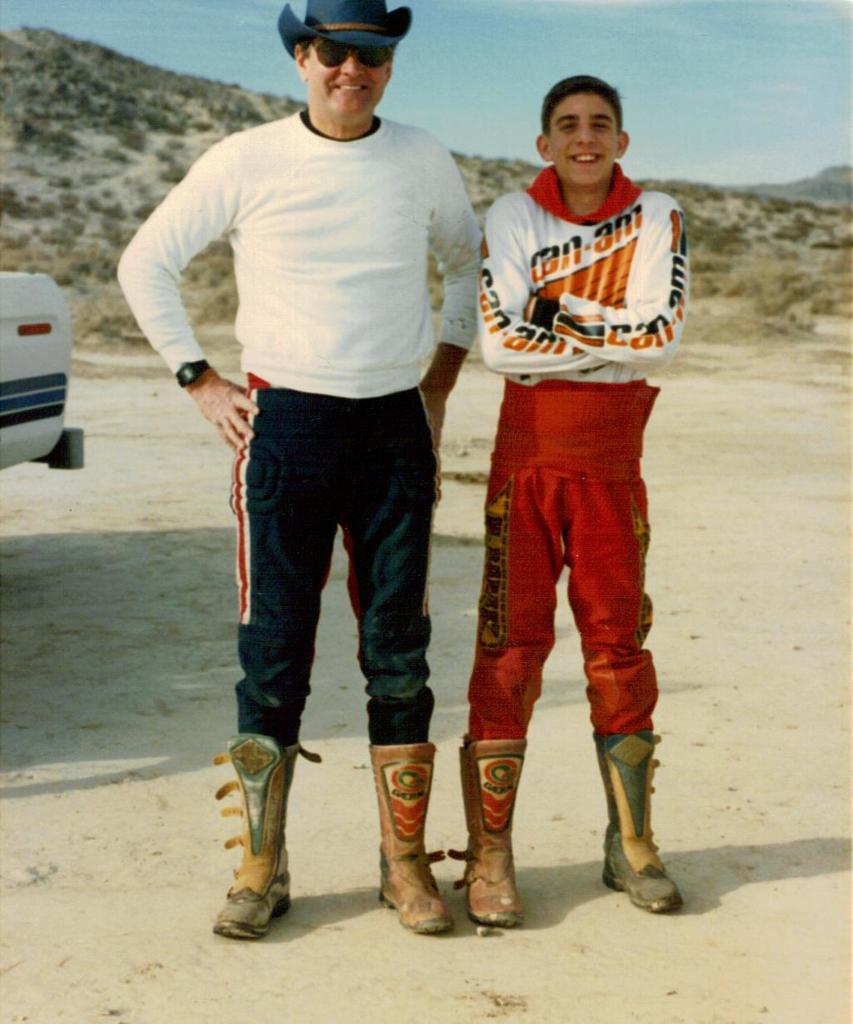<image>
Present a compact description of the photo's key features. Two men stand with the word can written on sleeve of the younger of them. 